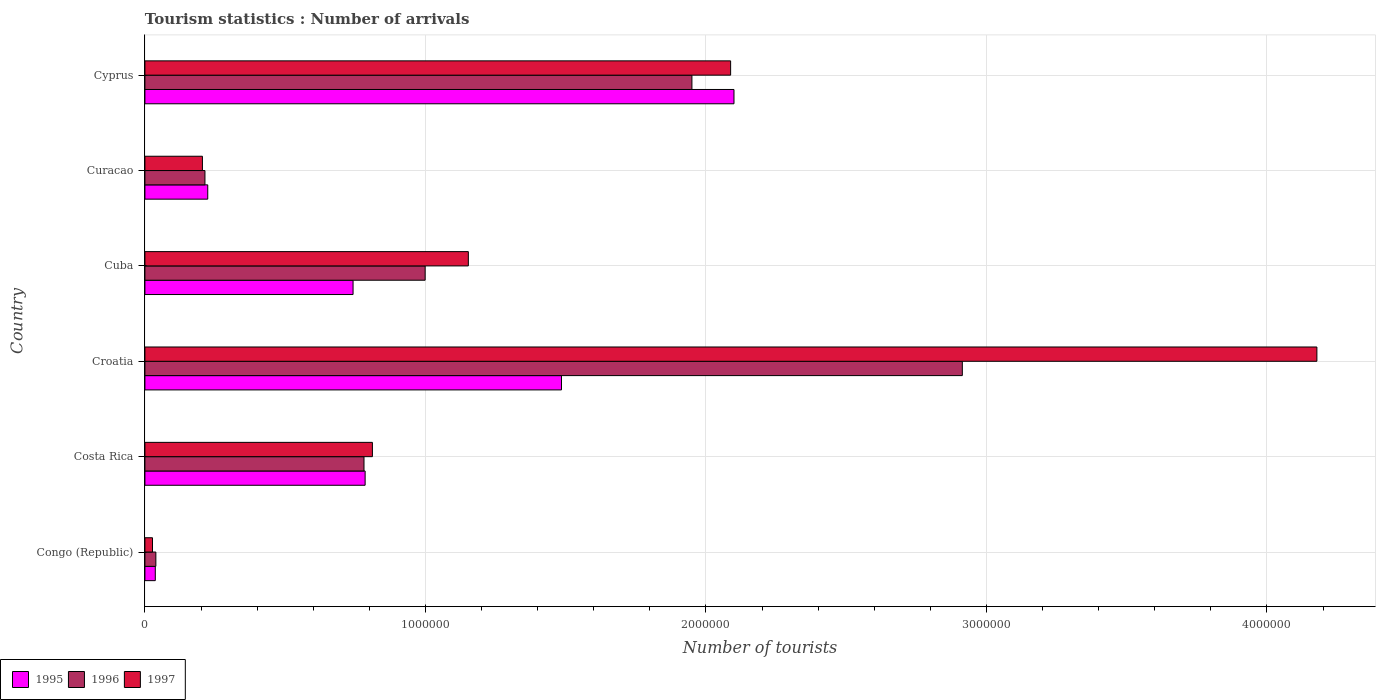How many different coloured bars are there?
Offer a very short reply. 3. Are the number of bars per tick equal to the number of legend labels?
Offer a very short reply. Yes. What is the label of the 6th group of bars from the top?
Offer a terse response. Congo (Republic). In how many cases, is the number of bars for a given country not equal to the number of legend labels?
Your response must be concise. 0. What is the number of tourist arrivals in 1995 in Cuba?
Offer a very short reply. 7.42e+05. Across all countries, what is the maximum number of tourist arrivals in 1997?
Ensure brevity in your answer.  4.18e+06. Across all countries, what is the minimum number of tourist arrivals in 1997?
Ensure brevity in your answer.  2.70e+04. In which country was the number of tourist arrivals in 1996 maximum?
Make the answer very short. Croatia. In which country was the number of tourist arrivals in 1995 minimum?
Ensure brevity in your answer.  Congo (Republic). What is the total number of tourist arrivals in 1997 in the graph?
Provide a short and direct response. 8.46e+06. What is the difference between the number of tourist arrivals in 1997 in Congo (Republic) and that in Curacao?
Provide a short and direct response. -1.78e+05. What is the difference between the number of tourist arrivals in 1997 in Cuba and the number of tourist arrivals in 1995 in Congo (Republic)?
Make the answer very short. 1.12e+06. What is the average number of tourist arrivals in 1997 per country?
Your answer should be very brief. 1.41e+06. What is the difference between the number of tourist arrivals in 1995 and number of tourist arrivals in 1997 in Cyprus?
Your response must be concise. 1.20e+04. In how many countries, is the number of tourist arrivals in 1997 greater than 2000000 ?
Keep it short and to the point. 2. What is the ratio of the number of tourist arrivals in 1996 in Congo (Republic) to that in Cuba?
Offer a terse response. 0.04. Is the number of tourist arrivals in 1997 in Congo (Republic) less than that in Costa Rica?
Offer a very short reply. Yes. Is the difference between the number of tourist arrivals in 1995 in Costa Rica and Croatia greater than the difference between the number of tourist arrivals in 1997 in Costa Rica and Croatia?
Ensure brevity in your answer.  Yes. What is the difference between the highest and the second highest number of tourist arrivals in 1996?
Offer a very short reply. 9.64e+05. What is the difference between the highest and the lowest number of tourist arrivals in 1997?
Your answer should be compact. 4.15e+06. In how many countries, is the number of tourist arrivals in 1996 greater than the average number of tourist arrivals in 1996 taken over all countries?
Your answer should be compact. 2. Is the sum of the number of tourist arrivals in 1997 in Costa Rica and Cyprus greater than the maximum number of tourist arrivals in 1996 across all countries?
Offer a terse response. No. What does the 2nd bar from the bottom in Congo (Republic) represents?
Your answer should be very brief. 1996. How many bars are there?
Provide a succinct answer. 18. How many countries are there in the graph?
Offer a very short reply. 6. Where does the legend appear in the graph?
Give a very brief answer. Bottom left. How are the legend labels stacked?
Give a very brief answer. Horizontal. What is the title of the graph?
Your answer should be very brief. Tourism statistics : Number of arrivals. Does "1964" appear as one of the legend labels in the graph?
Your answer should be very brief. No. What is the label or title of the X-axis?
Provide a short and direct response. Number of tourists. What is the Number of tourists of 1995 in Congo (Republic)?
Ensure brevity in your answer.  3.70e+04. What is the Number of tourists in 1996 in Congo (Republic)?
Keep it short and to the point. 3.90e+04. What is the Number of tourists of 1997 in Congo (Republic)?
Keep it short and to the point. 2.70e+04. What is the Number of tourists of 1995 in Costa Rica?
Your answer should be very brief. 7.85e+05. What is the Number of tourists in 1996 in Costa Rica?
Your answer should be compact. 7.81e+05. What is the Number of tourists in 1997 in Costa Rica?
Your response must be concise. 8.11e+05. What is the Number of tourists in 1995 in Croatia?
Make the answer very short. 1.48e+06. What is the Number of tourists of 1996 in Croatia?
Provide a short and direct response. 2.91e+06. What is the Number of tourists in 1997 in Croatia?
Offer a terse response. 4.18e+06. What is the Number of tourists of 1995 in Cuba?
Ensure brevity in your answer.  7.42e+05. What is the Number of tourists in 1996 in Cuba?
Provide a succinct answer. 9.99e+05. What is the Number of tourists of 1997 in Cuba?
Offer a very short reply. 1.15e+06. What is the Number of tourists of 1995 in Curacao?
Ensure brevity in your answer.  2.24e+05. What is the Number of tourists in 1996 in Curacao?
Ensure brevity in your answer.  2.14e+05. What is the Number of tourists of 1997 in Curacao?
Give a very brief answer. 2.05e+05. What is the Number of tourists of 1995 in Cyprus?
Provide a succinct answer. 2.10e+06. What is the Number of tourists of 1996 in Cyprus?
Give a very brief answer. 1.95e+06. What is the Number of tourists of 1997 in Cyprus?
Give a very brief answer. 2.09e+06. Across all countries, what is the maximum Number of tourists of 1995?
Your answer should be very brief. 2.10e+06. Across all countries, what is the maximum Number of tourists of 1996?
Offer a terse response. 2.91e+06. Across all countries, what is the maximum Number of tourists in 1997?
Make the answer very short. 4.18e+06. Across all countries, what is the minimum Number of tourists in 1995?
Give a very brief answer. 3.70e+04. Across all countries, what is the minimum Number of tourists of 1996?
Provide a short and direct response. 3.90e+04. Across all countries, what is the minimum Number of tourists in 1997?
Provide a short and direct response. 2.70e+04. What is the total Number of tourists of 1995 in the graph?
Provide a succinct answer. 5.37e+06. What is the total Number of tourists of 1996 in the graph?
Your response must be concise. 6.90e+06. What is the total Number of tourists in 1997 in the graph?
Offer a very short reply. 8.46e+06. What is the difference between the Number of tourists of 1995 in Congo (Republic) and that in Costa Rica?
Your response must be concise. -7.48e+05. What is the difference between the Number of tourists in 1996 in Congo (Republic) and that in Costa Rica?
Make the answer very short. -7.42e+05. What is the difference between the Number of tourists in 1997 in Congo (Republic) and that in Costa Rica?
Offer a terse response. -7.84e+05. What is the difference between the Number of tourists of 1995 in Congo (Republic) and that in Croatia?
Your response must be concise. -1.45e+06. What is the difference between the Number of tourists in 1996 in Congo (Republic) and that in Croatia?
Your answer should be compact. -2.88e+06. What is the difference between the Number of tourists of 1997 in Congo (Republic) and that in Croatia?
Offer a very short reply. -4.15e+06. What is the difference between the Number of tourists in 1995 in Congo (Republic) and that in Cuba?
Provide a succinct answer. -7.05e+05. What is the difference between the Number of tourists of 1996 in Congo (Republic) and that in Cuba?
Your response must be concise. -9.60e+05. What is the difference between the Number of tourists of 1997 in Congo (Republic) and that in Cuba?
Your answer should be very brief. -1.13e+06. What is the difference between the Number of tourists in 1995 in Congo (Republic) and that in Curacao?
Make the answer very short. -1.87e+05. What is the difference between the Number of tourists in 1996 in Congo (Republic) and that in Curacao?
Provide a succinct answer. -1.75e+05. What is the difference between the Number of tourists in 1997 in Congo (Republic) and that in Curacao?
Provide a short and direct response. -1.78e+05. What is the difference between the Number of tourists in 1995 in Congo (Republic) and that in Cyprus?
Provide a short and direct response. -2.06e+06. What is the difference between the Number of tourists of 1996 in Congo (Republic) and that in Cyprus?
Give a very brief answer. -1.91e+06. What is the difference between the Number of tourists of 1997 in Congo (Republic) and that in Cyprus?
Provide a short and direct response. -2.06e+06. What is the difference between the Number of tourists in 1995 in Costa Rica and that in Croatia?
Provide a succinct answer. -7.00e+05. What is the difference between the Number of tourists in 1996 in Costa Rica and that in Croatia?
Offer a very short reply. -2.13e+06. What is the difference between the Number of tourists of 1997 in Costa Rica and that in Croatia?
Your answer should be very brief. -3.37e+06. What is the difference between the Number of tourists in 1995 in Costa Rica and that in Cuba?
Make the answer very short. 4.30e+04. What is the difference between the Number of tourists of 1996 in Costa Rica and that in Cuba?
Provide a short and direct response. -2.18e+05. What is the difference between the Number of tourists of 1997 in Costa Rica and that in Cuba?
Provide a short and direct response. -3.42e+05. What is the difference between the Number of tourists in 1995 in Costa Rica and that in Curacao?
Your response must be concise. 5.61e+05. What is the difference between the Number of tourists in 1996 in Costa Rica and that in Curacao?
Give a very brief answer. 5.67e+05. What is the difference between the Number of tourists in 1997 in Costa Rica and that in Curacao?
Give a very brief answer. 6.06e+05. What is the difference between the Number of tourists in 1995 in Costa Rica and that in Cyprus?
Offer a very short reply. -1.32e+06. What is the difference between the Number of tourists of 1996 in Costa Rica and that in Cyprus?
Your answer should be very brief. -1.17e+06. What is the difference between the Number of tourists of 1997 in Costa Rica and that in Cyprus?
Your answer should be very brief. -1.28e+06. What is the difference between the Number of tourists of 1995 in Croatia and that in Cuba?
Provide a short and direct response. 7.43e+05. What is the difference between the Number of tourists of 1996 in Croatia and that in Cuba?
Ensure brevity in your answer.  1.92e+06. What is the difference between the Number of tourists of 1997 in Croatia and that in Cuba?
Your answer should be compact. 3.02e+06. What is the difference between the Number of tourists of 1995 in Croatia and that in Curacao?
Keep it short and to the point. 1.26e+06. What is the difference between the Number of tourists in 1996 in Croatia and that in Curacao?
Provide a succinct answer. 2.70e+06. What is the difference between the Number of tourists of 1997 in Croatia and that in Curacao?
Your answer should be very brief. 3.97e+06. What is the difference between the Number of tourists of 1995 in Croatia and that in Cyprus?
Your response must be concise. -6.15e+05. What is the difference between the Number of tourists of 1996 in Croatia and that in Cyprus?
Give a very brief answer. 9.64e+05. What is the difference between the Number of tourists of 1997 in Croatia and that in Cyprus?
Your answer should be compact. 2.09e+06. What is the difference between the Number of tourists of 1995 in Cuba and that in Curacao?
Your response must be concise. 5.18e+05. What is the difference between the Number of tourists in 1996 in Cuba and that in Curacao?
Provide a succinct answer. 7.85e+05. What is the difference between the Number of tourists of 1997 in Cuba and that in Curacao?
Make the answer very short. 9.48e+05. What is the difference between the Number of tourists of 1995 in Cuba and that in Cyprus?
Offer a very short reply. -1.36e+06. What is the difference between the Number of tourists of 1996 in Cuba and that in Cyprus?
Give a very brief answer. -9.51e+05. What is the difference between the Number of tourists in 1997 in Cuba and that in Cyprus?
Make the answer very short. -9.35e+05. What is the difference between the Number of tourists of 1995 in Curacao and that in Cyprus?
Offer a terse response. -1.88e+06. What is the difference between the Number of tourists of 1996 in Curacao and that in Cyprus?
Offer a terse response. -1.74e+06. What is the difference between the Number of tourists of 1997 in Curacao and that in Cyprus?
Give a very brief answer. -1.88e+06. What is the difference between the Number of tourists in 1995 in Congo (Republic) and the Number of tourists in 1996 in Costa Rica?
Offer a terse response. -7.44e+05. What is the difference between the Number of tourists in 1995 in Congo (Republic) and the Number of tourists in 1997 in Costa Rica?
Give a very brief answer. -7.74e+05. What is the difference between the Number of tourists in 1996 in Congo (Republic) and the Number of tourists in 1997 in Costa Rica?
Offer a very short reply. -7.72e+05. What is the difference between the Number of tourists in 1995 in Congo (Republic) and the Number of tourists in 1996 in Croatia?
Provide a short and direct response. -2.88e+06. What is the difference between the Number of tourists of 1995 in Congo (Republic) and the Number of tourists of 1997 in Croatia?
Give a very brief answer. -4.14e+06. What is the difference between the Number of tourists of 1996 in Congo (Republic) and the Number of tourists of 1997 in Croatia?
Your response must be concise. -4.14e+06. What is the difference between the Number of tourists of 1995 in Congo (Republic) and the Number of tourists of 1996 in Cuba?
Provide a short and direct response. -9.62e+05. What is the difference between the Number of tourists in 1995 in Congo (Republic) and the Number of tourists in 1997 in Cuba?
Your answer should be very brief. -1.12e+06. What is the difference between the Number of tourists in 1996 in Congo (Republic) and the Number of tourists in 1997 in Cuba?
Give a very brief answer. -1.11e+06. What is the difference between the Number of tourists in 1995 in Congo (Republic) and the Number of tourists in 1996 in Curacao?
Your response must be concise. -1.77e+05. What is the difference between the Number of tourists in 1995 in Congo (Republic) and the Number of tourists in 1997 in Curacao?
Provide a succinct answer. -1.68e+05. What is the difference between the Number of tourists in 1996 in Congo (Republic) and the Number of tourists in 1997 in Curacao?
Give a very brief answer. -1.66e+05. What is the difference between the Number of tourists of 1995 in Congo (Republic) and the Number of tourists of 1996 in Cyprus?
Ensure brevity in your answer.  -1.91e+06. What is the difference between the Number of tourists of 1995 in Congo (Republic) and the Number of tourists of 1997 in Cyprus?
Offer a very short reply. -2.05e+06. What is the difference between the Number of tourists in 1996 in Congo (Republic) and the Number of tourists in 1997 in Cyprus?
Your response must be concise. -2.05e+06. What is the difference between the Number of tourists of 1995 in Costa Rica and the Number of tourists of 1996 in Croatia?
Provide a succinct answer. -2.13e+06. What is the difference between the Number of tourists of 1995 in Costa Rica and the Number of tourists of 1997 in Croatia?
Give a very brief answer. -3.39e+06. What is the difference between the Number of tourists in 1996 in Costa Rica and the Number of tourists in 1997 in Croatia?
Provide a succinct answer. -3.40e+06. What is the difference between the Number of tourists of 1995 in Costa Rica and the Number of tourists of 1996 in Cuba?
Offer a terse response. -2.14e+05. What is the difference between the Number of tourists of 1995 in Costa Rica and the Number of tourists of 1997 in Cuba?
Keep it short and to the point. -3.68e+05. What is the difference between the Number of tourists of 1996 in Costa Rica and the Number of tourists of 1997 in Cuba?
Give a very brief answer. -3.72e+05. What is the difference between the Number of tourists of 1995 in Costa Rica and the Number of tourists of 1996 in Curacao?
Give a very brief answer. 5.71e+05. What is the difference between the Number of tourists of 1995 in Costa Rica and the Number of tourists of 1997 in Curacao?
Provide a succinct answer. 5.80e+05. What is the difference between the Number of tourists of 1996 in Costa Rica and the Number of tourists of 1997 in Curacao?
Ensure brevity in your answer.  5.76e+05. What is the difference between the Number of tourists in 1995 in Costa Rica and the Number of tourists in 1996 in Cyprus?
Offer a very short reply. -1.16e+06. What is the difference between the Number of tourists of 1995 in Costa Rica and the Number of tourists of 1997 in Cyprus?
Give a very brief answer. -1.30e+06. What is the difference between the Number of tourists of 1996 in Costa Rica and the Number of tourists of 1997 in Cyprus?
Provide a short and direct response. -1.31e+06. What is the difference between the Number of tourists of 1995 in Croatia and the Number of tourists of 1996 in Cuba?
Offer a very short reply. 4.86e+05. What is the difference between the Number of tourists in 1995 in Croatia and the Number of tourists in 1997 in Cuba?
Offer a very short reply. 3.32e+05. What is the difference between the Number of tourists of 1996 in Croatia and the Number of tourists of 1997 in Cuba?
Give a very brief answer. 1.76e+06. What is the difference between the Number of tourists in 1995 in Croatia and the Number of tourists in 1996 in Curacao?
Keep it short and to the point. 1.27e+06. What is the difference between the Number of tourists of 1995 in Croatia and the Number of tourists of 1997 in Curacao?
Keep it short and to the point. 1.28e+06. What is the difference between the Number of tourists in 1996 in Croatia and the Number of tourists in 1997 in Curacao?
Your answer should be very brief. 2.71e+06. What is the difference between the Number of tourists of 1995 in Croatia and the Number of tourists of 1996 in Cyprus?
Offer a terse response. -4.65e+05. What is the difference between the Number of tourists of 1995 in Croatia and the Number of tourists of 1997 in Cyprus?
Keep it short and to the point. -6.03e+05. What is the difference between the Number of tourists in 1996 in Croatia and the Number of tourists in 1997 in Cyprus?
Ensure brevity in your answer.  8.26e+05. What is the difference between the Number of tourists of 1995 in Cuba and the Number of tourists of 1996 in Curacao?
Your answer should be very brief. 5.28e+05. What is the difference between the Number of tourists of 1995 in Cuba and the Number of tourists of 1997 in Curacao?
Provide a succinct answer. 5.37e+05. What is the difference between the Number of tourists in 1996 in Cuba and the Number of tourists in 1997 in Curacao?
Your answer should be very brief. 7.94e+05. What is the difference between the Number of tourists of 1995 in Cuba and the Number of tourists of 1996 in Cyprus?
Your answer should be compact. -1.21e+06. What is the difference between the Number of tourists in 1995 in Cuba and the Number of tourists in 1997 in Cyprus?
Your answer should be compact. -1.35e+06. What is the difference between the Number of tourists of 1996 in Cuba and the Number of tourists of 1997 in Cyprus?
Ensure brevity in your answer.  -1.09e+06. What is the difference between the Number of tourists in 1995 in Curacao and the Number of tourists in 1996 in Cyprus?
Provide a succinct answer. -1.73e+06. What is the difference between the Number of tourists in 1995 in Curacao and the Number of tourists in 1997 in Cyprus?
Offer a terse response. -1.86e+06. What is the difference between the Number of tourists in 1996 in Curacao and the Number of tourists in 1997 in Cyprus?
Offer a terse response. -1.87e+06. What is the average Number of tourists of 1995 per country?
Provide a succinct answer. 8.96e+05. What is the average Number of tourists of 1996 per country?
Provide a succinct answer. 1.15e+06. What is the average Number of tourists of 1997 per country?
Your answer should be very brief. 1.41e+06. What is the difference between the Number of tourists of 1995 and Number of tourists of 1996 in Congo (Republic)?
Your answer should be very brief. -2000. What is the difference between the Number of tourists in 1996 and Number of tourists in 1997 in Congo (Republic)?
Make the answer very short. 1.20e+04. What is the difference between the Number of tourists of 1995 and Number of tourists of 1996 in Costa Rica?
Offer a very short reply. 4000. What is the difference between the Number of tourists in 1995 and Number of tourists in 1997 in Costa Rica?
Keep it short and to the point. -2.60e+04. What is the difference between the Number of tourists in 1995 and Number of tourists in 1996 in Croatia?
Your answer should be very brief. -1.43e+06. What is the difference between the Number of tourists in 1995 and Number of tourists in 1997 in Croatia?
Your answer should be very brief. -2.69e+06. What is the difference between the Number of tourists in 1996 and Number of tourists in 1997 in Croatia?
Offer a terse response. -1.26e+06. What is the difference between the Number of tourists of 1995 and Number of tourists of 1996 in Cuba?
Your answer should be very brief. -2.57e+05. What is the difference between the Number of tourists of 1995 and Number of tourists of 1997 in Cuba?
Provide a succinct answer. -4.11e+05. What is the difference between the Number of tourists in 1996 and Number of tourists in 1997 in Cuba?
Your answer should be very brief. -1.54e+05. What is the difference between the Number of tourists of 1995 and Number of tourists of 1997 in Curacao?
Your response must be concise. 1.90e+04. What is the difference between the Number of tourists of 1996 and Number of tourists of 1997 in Curacao?
Ensure brevity in your answer.  9000. What is the difference between the Number of tourists in 1995 and Number of tourists in 1996 in Cyprus?
Your response must be concise. 1.50e+05. What is the difference between the Number of tourists in 1995 and Number of tourists in 1997 in Cyprus?
Keep it short and to the point. 1.20e+04. What is the difference between the Number of tourists in 1996 and Number of tourists in 1997 in Cyprus?
Offer a very short reply. -1.38e+05. What is the ratio of the Number of tourists in 1995 in Congo (Republic) to that in Costa Rica?
Provide a succinct answer. 0.05. What is the ratio of the Number of tourists of 1996 in Congo (Republic) to that in Costa Rica?
Ensure brevity in your answer.  0.05. What is the ratio of the Number of tourists of 1997 in Congo (Republic) to that in Costa Rica?
Ensure brevity in your answer.  0.03. What is the ratio of the Number of tourists of 1995 in Congo (Republic) to that in Croatia?
Your answer should be compact. 0.02. What is the ratio of the Number of tourists in 1996 in Congo (Republic) to that in Croatia?
Provide a succinct answer. 0.01. What is the ratio of the Number of tourists of 1997 in Congo (Republic) to that in Croatia?
Keep it short and to the point. 0.01. What is the ratio of the Number of tourists in 1995 in Congo (Republic) to that in Cuba?
Offer a terse response. 0.05. What is the ratio of the Number of tourists of 1996 in Congo (Republic) to that in Cuba?
Provide a succinct answer. 0.04. What is the ratio of the Number of tourists of 1997 in Congo (Republic) to that in Cuba?
Provide a succinct answer. 0.02. What is the ratio of the Number of tourists of 1995 in Congo (Republic) to that in Curacao?
Provide a short and direct response. 0.17. What is the ratio of the Number of tourists in 1996 in Congo (Republic) to that in Curacao?
Make the answer very short. 0.18. What is the ratio of the Number of tourists in 1997 in Congo (Republic) to that in Curacao?
Your answer should be compact. 0.13. What is the ratio of the Number of tourists of 1995 in Congo (Republic) to that in Cyprus?
Provide a short and direct response. 0.02. What is the ratio of the Number of tourists of 1997 in Congo (Republic) to that in Cyprus?
Make the answer very short. 0.01. What is the ratio of the Number of tourists of 1995 in Costa Rica to that in Croatia?
Provide a short and direct response. 0.53. What is the ratio of the Number of tourists of 1996 in Costa Rica to that in Croatia?
Give a very brief answer. 0.27. What is the ratio of the Number of tourists in 1997 in Costa Rica to that in Croatia?
Make the answer very short. 0.19. What is the ratio of the Number of tourists of 1995 in Costa Rica to that in Cuba?
Ensure brevity in your answer.  1.06. What is the ratio of the Number of tourists in 1996 in Costa Rica to that in Cuba?
Keep it short and to the point. 0.78. What is the ratio of the Number of tourists in 1997 in Costa Rica to that in Cuba?
Offer a terse response. 0.7. What is the ratio of the Number of tourists of 1995 in Costa Rica to that in Curacao?
Keep it short and to the point. 3.5. What is the ratio of the Number of tourists of 1996 in Costa Rica to that in Curacao?
Offer a terse response. 3.65. What is the ratio of the Number of tourists in 1997 in Costa Rica to that in Curacao?
Give a very brief answer. 3.96. What is the ratio of the Number of tourists of 1995 in Costa Rica to that in Cyprus?
Give a very brief answer. 0.37. What is the ratio of the Number of tourists of 1996 in Costa Rica to that in Cyprus?
Provide a short and direct response. 0.4. What is the ratio of the Number of tourists of 1997 in Costa Rica to that in Cyprus?
Your answer should be very brief. 0.39. What is the ratio of the Number of tourists of 1995 in Croatia to that in Cuba?
Your answer should be very brief. 2. What is the ratio of the Number of tourists in 1996 in Croatia to that in Cuba?
Offer a terse response. 2.92. What is the ratio of the Number of tourists in 1997 in Croatia to that in Cuba?
Make the answer very short. 3.62. What is the ratio of the Number of tourists of 1995 in Croatia to that in Curacao?
Make the answer very short. 6.63. What is the ratio of the Number of tourists in 1996 in Croatia to that in Curacao?
Make the answer very short. 13.62. What is the ratio of the Number of tourists in 1997 in Croatia to that in Curacao?
Ensure brevity in your answer.  20.38. What is the ratio of the Number of tourists in 1995 in Croatia to that in Cyprus?
Your answer should be compact. 0.71. What is the ratio of the Number of tourists in 1996 in Croatia to that in Cyprus?
Offer a terse response. 1.49. What is the ratio of the Number of tourists of 1997 in Croatia to that in Cyprus?
Ensure brevity in your answer.  2. What is the ratio of the Number of tourists of 1995 in Cuba to that in Curacao?
Keep it short and to the point. 3.31. What is the ratio of the Number of tourists of 1996 in Cuba to that in Curacao?
Offer a very short reply. 4.67. What is the ratio of the Number of tourists in 1997 in Cuba to that in Curacao?
Offer a very short reply. 5.62. What is the ratio of the Number of tourists in 1995 in Cuba to that in Cyprus?
Offer a terse response. 0.35. What is the ratio of the Number of tourists in 1996 in Cuba to that in Cyprus?
Offer a terse response. 0.51. What is the ratio of the Number of tourists in 1997 in Cuba to that in Cyprus?
Keep it short and to the point. 0.55. What is the ratio of the Number of tourists of 1995 in Curacao to that in Cyprus?
Your answer should be compact. 0.11. What is the ratio of the Number of tourists in 1996 in Curacao to that in Cyprus?
Keep it short and to the point. 0.11. What is the ratio of the Number of tourists in 1997 in Curacao to that in Cyprus?
Make the answer very short. 0.1. What is the difference between the highest and the second highest Number of tourists in 1995?
Make the answer very short. 6.15e+05. What is the difference between the highest and the second highest Number of tourists of 1996?
Give a very brief answer. 9.64e+05. What is the difference between the highest and the second highest Number of tourists of 1997?
Your response must be concise. 2.09e+06. What is the difference between the highest and the lowest Number of tourists in 1995?
Your answer should be very brief. 2.06e+06. What is the difference between the highest and the lowest Number of tourists of 1996?
Provide a succinct answer. 2.88e+06. What is the difference between the highest and the lowest Number of tourists of 1997?
Provide a succinct answer. 4.15e+06. 